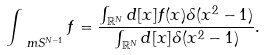Convert formula to latex. <formula><loc_0><loc_0><loc_500><loc_500>\int _ { \ m S ^ { N - 1 } } f = \frac { \int _ { \mathbb { R } ^ { N } } d [ x ] f ( x ) \delta ( x ^ { 2 } - 1 ) } { \int _ { \mathbb { R } ^ { N } } d [ x ] \delta ( x ^ { 2 } - 1 ) } .</formula> 